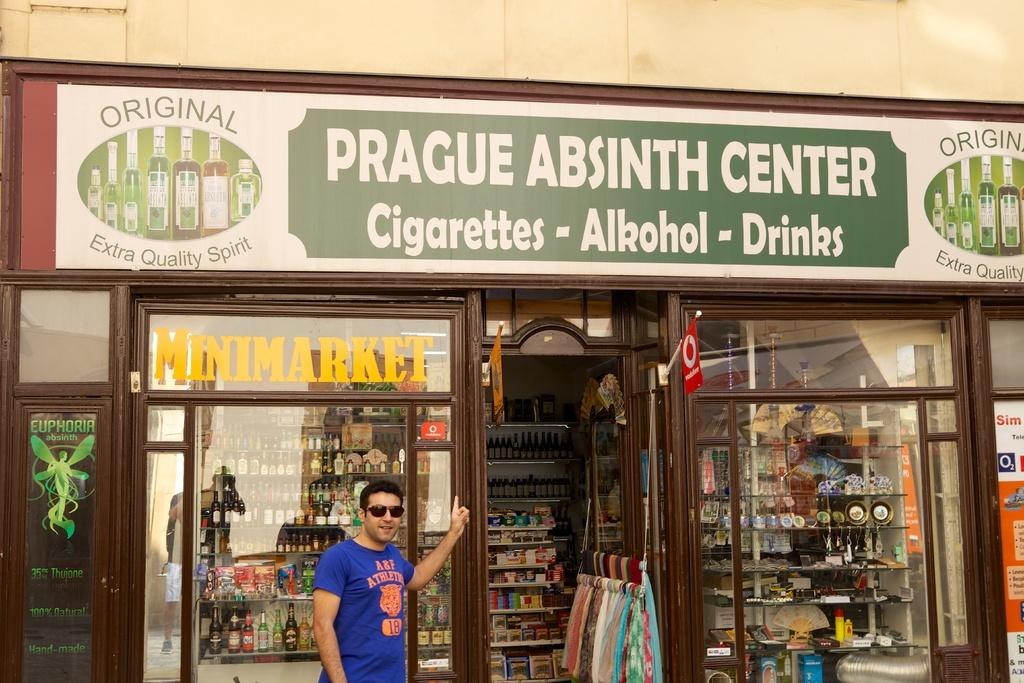Provide a one-sentence caption for the provided image. A man stands outside the Prague Absinth Center. 